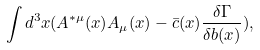<formula> <loc_0><loc_0><loc_500><loc_500>\int d ^ { 3 } x ( A ^ { * \mu } ( x ) A _ { \mu } ( x ) - \bar { c } ( x ) \frac { \delta \Gamma } { \delta b ( x ) } ) ,</formula> 